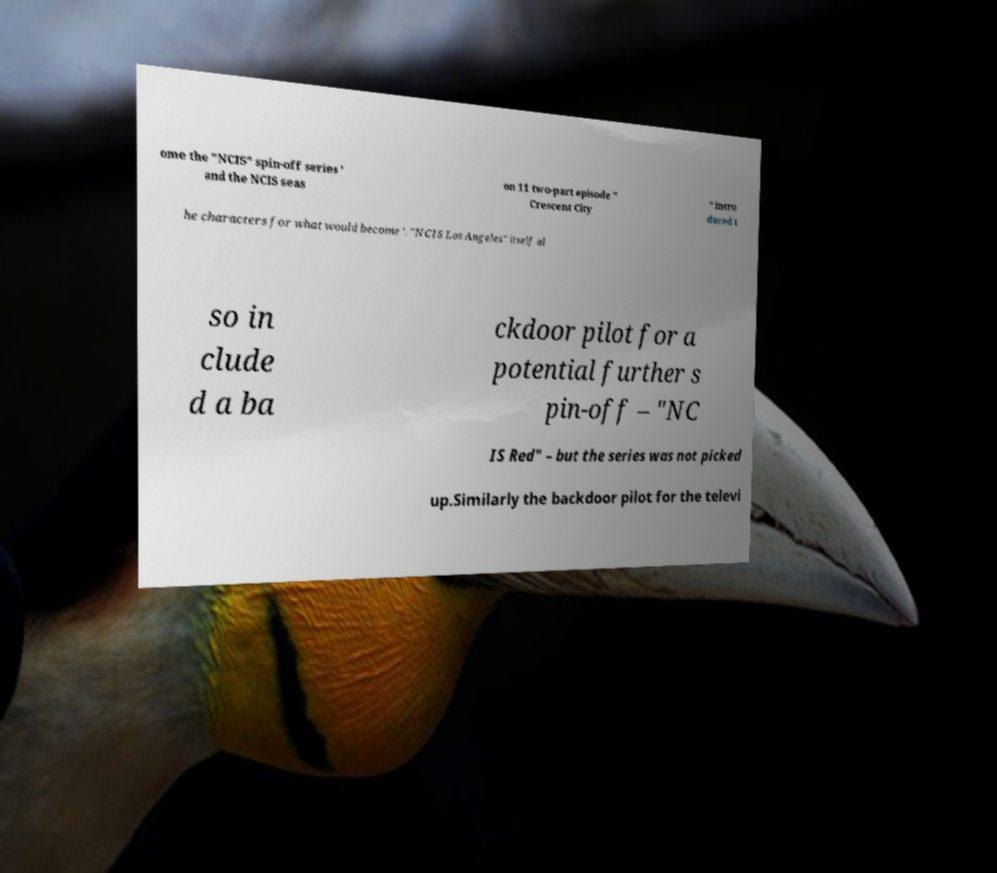What messages or text are displayed in this image? I need them in a readable, typed format. ome the "NCIS" spin-off series ' and the NCIS seas on 11 two-part episode " Crescent City " intro duced t he characters for what would become '. "NCIS Los Angeles" itself al so in clude d a ba ckdoor pilot for a potential further s pin-off – "NC IS Red" – but the series was not picked up.Similarly the backdoor pilot for the televi 